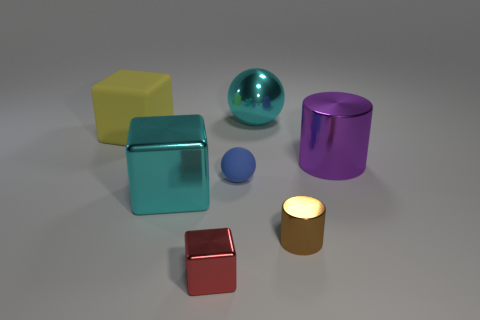Subtract all metallic blocks. How many blocks are left? 1 Subtract 1 cubes. How many cubes are left? 2 Subtract all red cubes. How many cubes are left? 2 Add 2 big yellow rubber blocks. How many objects exist? 9 Subtract all gray cubes. Subtract all purple spheres. How many cubes are left? 3 Subtract all big gray matte cubes. Subtract all large rubber objects. How many objects are left? 6 Add 3 large purple cylinders. How many large purple cylinders are left? 4 Add 3 yellow things. How many yellow things exist? 4 Subtract 0 green spheres. How many objects are left? 7 Subtract all blocks. How many objects are left? 4 